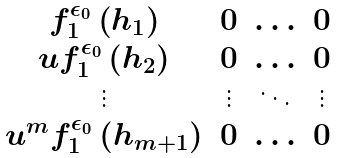Convert formula to latex. <formula><loc_0><loc_0><loc_500><loc_500>\begin{matrix} f ^ { \epsilon _ { 0 } } _ { 1 } \left ( h _ { 1 } \right ) & 0 & \hdots & 0 \\ u f ^ { \epsilon _ { 0 } } _ { 1 } \left ( h _ { 2 } \right ) & 0 & \hdots & 0 \\ \vdots & \vdots & \ddots & \vdots \\ u ^ { m } f ^ { \epsilon _ { 0 } } _ { 1 } \left ( h _ { m + 1 } \right ) & 0 & \hdots & 0 \end{matrix}</formula> 